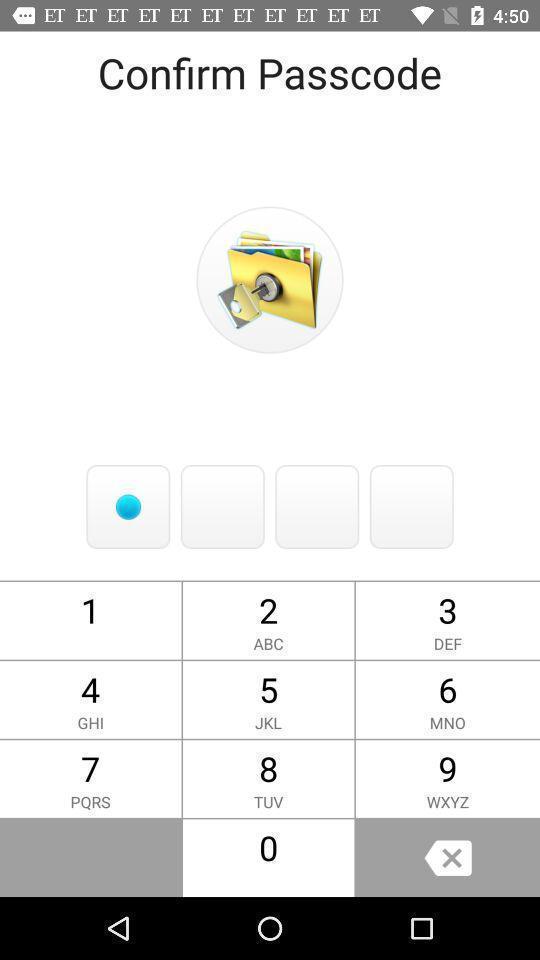Summarize the main components in this picture. Screen shows passcode page in photo app. 